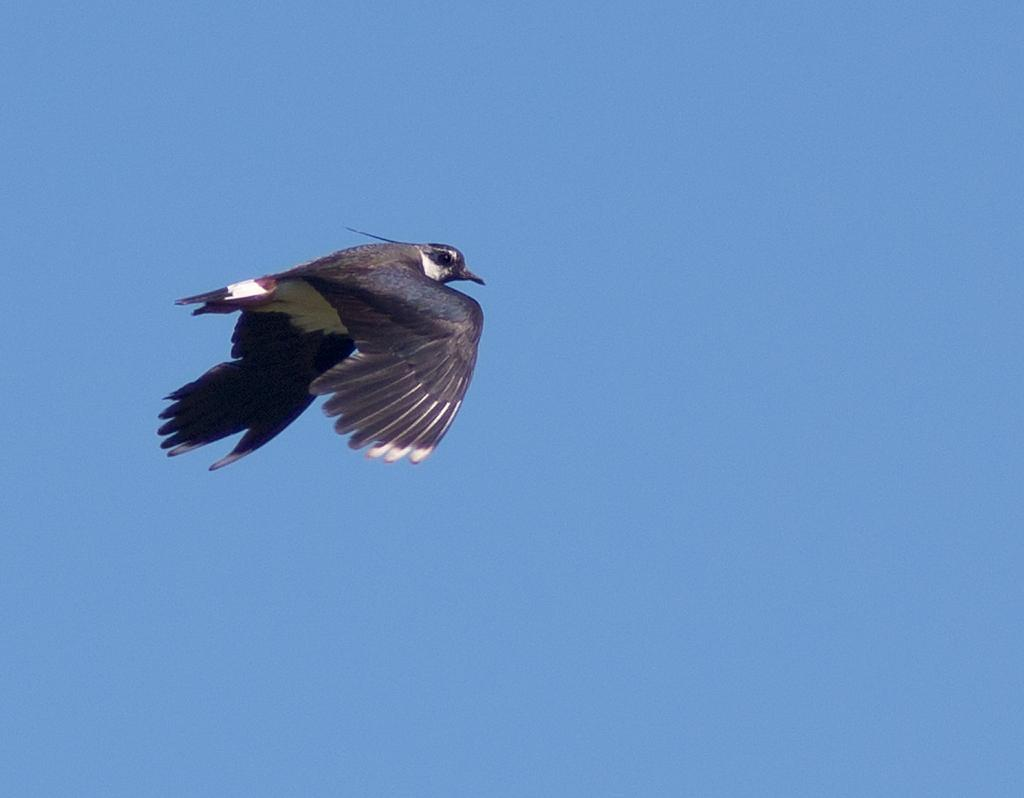What type of bird can be seen in the image? There is a black color bird in the image. What is the bird doing in the image? The bird is flying in the air. What can be seen in the background of the image? The sky is visible in the background of the image. What is the color of the sky in the image? The sky is blue in the image. How much money is the bird carrying in the image? The bird is not carrying any money in the image; it is simply flying. 